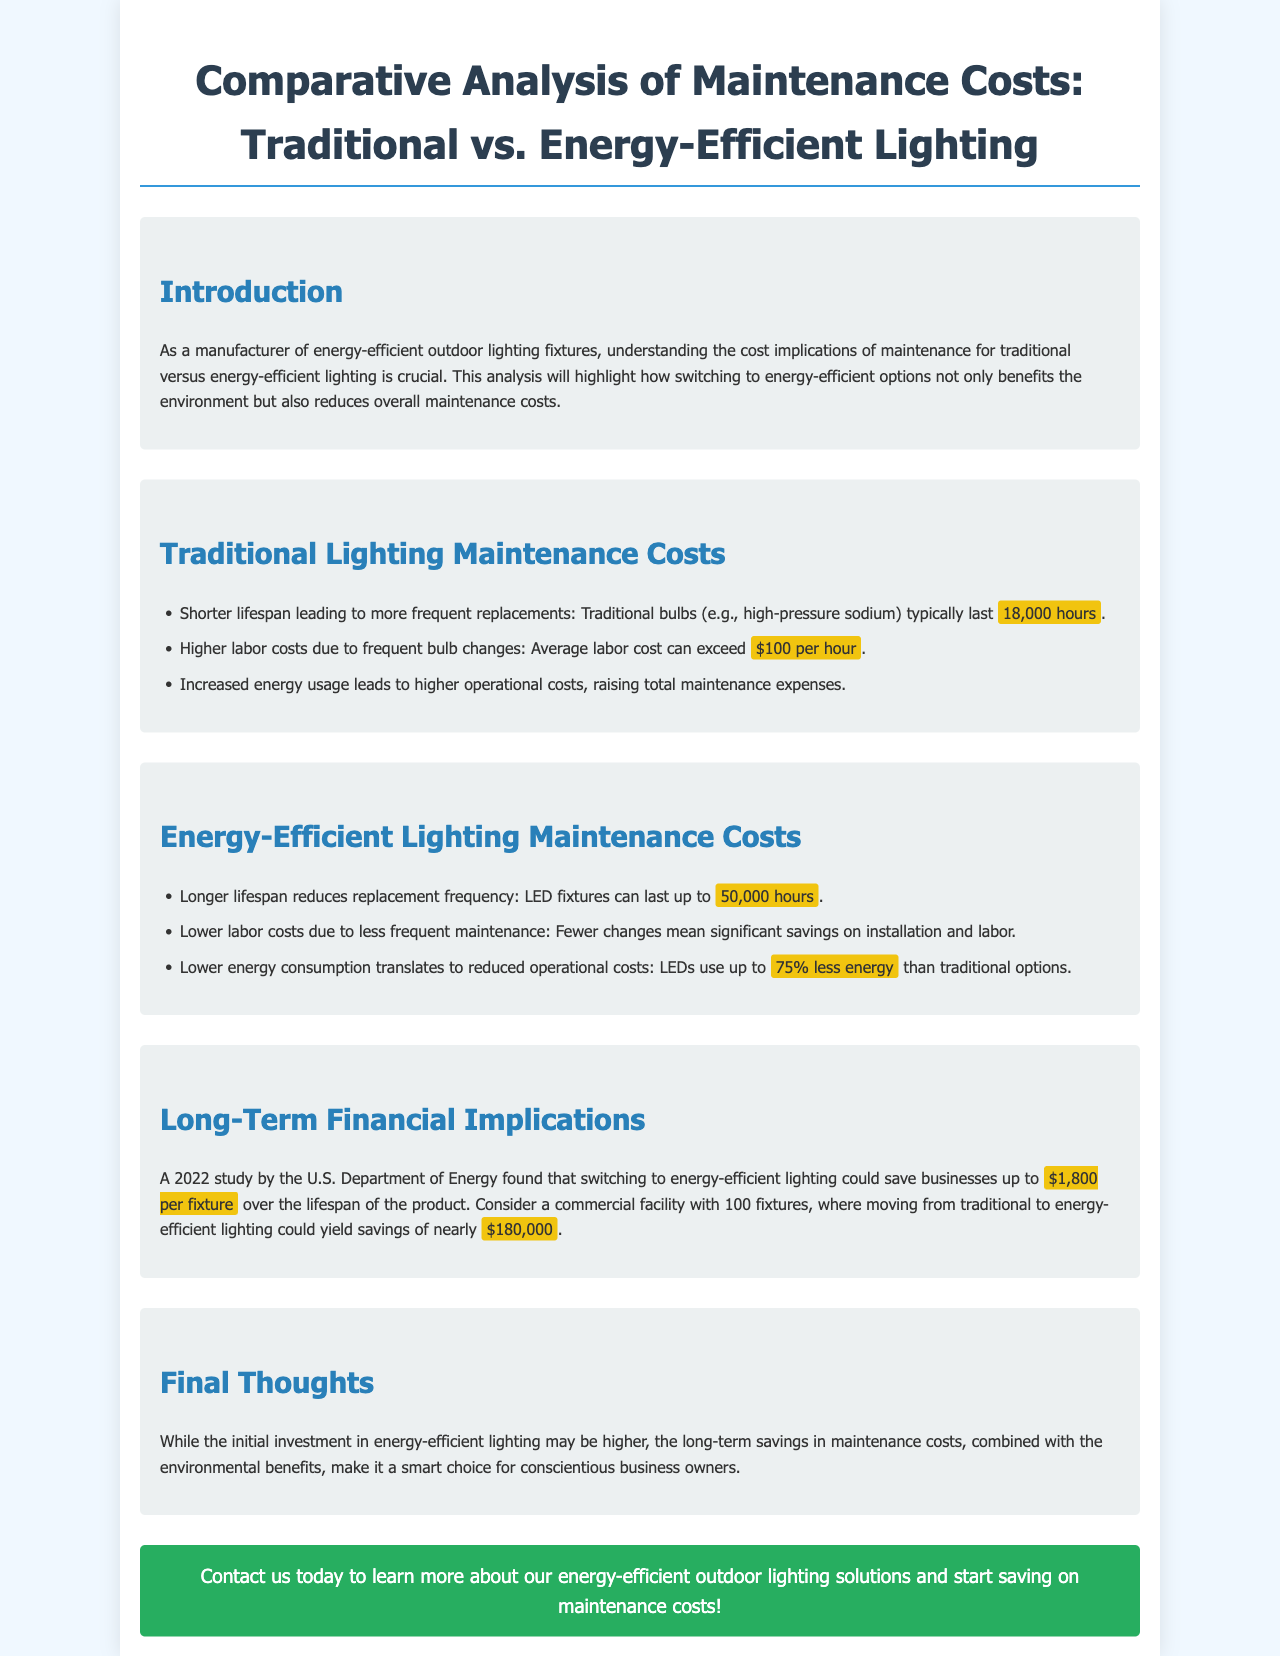What is the lifespan of traditional bulbs? The document states that traditional bulbs typically last 18,000 hours.
Answer: 18,000 hours What is the average labor cost for traditional lighting maintenance? The average labor cost mentioned for traditional lighting maintenance can exceed $100 per hour.
Answer: $100 per hour How much energy can LEDs save compared to traditional options? The document mentions that LEDs can use up to 75% less energy than traditional options.
Answer: 75% less energy What is the savings per fixture when switching to energy-efficient lighting? A 2022 study by the U.S. Department of Energy found that switching could save businesses up to $1,800 per fixture.
Answer: $1,800 per fixture What is the total potential savings for 100 fixtures? The document states that savings could yield nearly $180,000 for 100 fixtures.
Answer: $180,000 How long do LED fixtures last? According to the document, LED fixtures can last up to 50,000 hours.
Answer: 50,000 hours What is the focus of this brochure? The brochure focuses on the comparative analysis of maintenance costs for traditional versus energy-efficient lighting.
Answer: Comparative analysis of maintenance costs What does the document advise business owners considering energy-efficient lighting? The document advises that despite a higher initial investment, the long-term savings in maintenance costs make it a smart choice.
Answer: Smart choice 